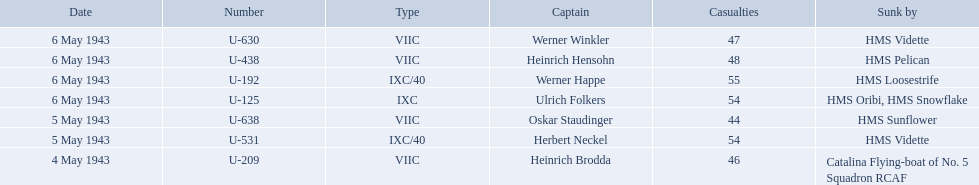What boats were lost on may 5? U-638, U-531. Who were the captains of those boats? Oskar Staudinger, Herbert Neckel. Which captain was not oskar staudinger? Herbert Neckel. 